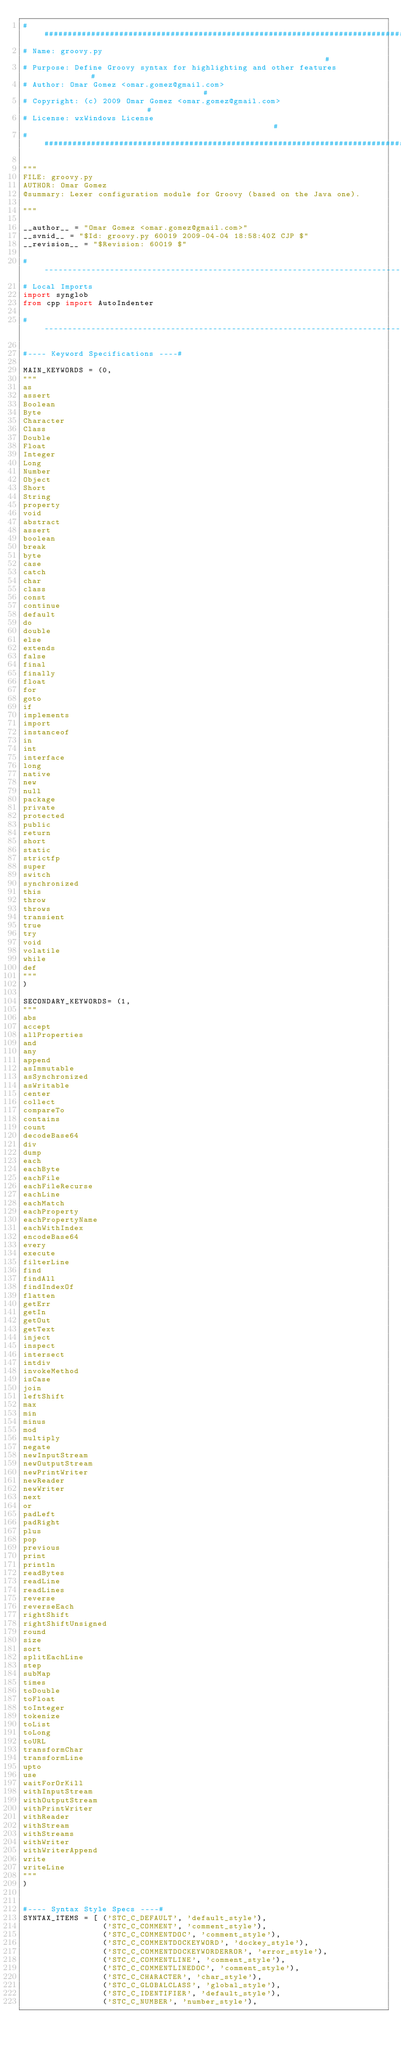<code> <loc_0><loc_0><loc_500><loc_500><_Python_>###############################################################################
# Name: groovy.py                                                             #
# Purpose: Define Groovy syntax for highlighting and other features           #
# Author: Omar Gomez <omar.gomez@gmail.com>                                   #
# Copyright: (c) 2009 Omar Gomez <omar.gomez@gmail.com>                       #
# License: wxWindows License                                                  #
###############################################################################

"""
FILE: groovy.py
AUTHOR: Omar Gomez
@summary: Lexer configuration module for Groovy (based on the Java one).

"""

__author__ = "Omar Gomez <omar.gomez@gmail.com>"
__svnid__ = "$Id: groovy.py 60019 2009-04-04 18:58:40Z CJP $"
__revision__ = "$Revision: 60019 $"

#-----------------------------------------------------------------------------#
# Local Imports
import synglob
from cpp import AutoIndenter

#-----------------------------------------------------------------------------#

#---- Keyword Specifications ----#

MAIN_KEYWORDS = (0, 
"""
as
assert
Boolean
Byte
Character
Class
Double
Float
Integer
Long
Number
Object
Short
String
property
void
abstract
assert
boolean
break
byte
case
catch
char
class
const
continue
default
do
double
else
extends
false
final
finally
float
for
goto
if
implements
import
instanceof
in
int
interface
long
native
new
null
package
private
protected
public
return
short
static
strictfp
super
switch
synchronized
this
throw
throws
transient
true
try
void
volatile
while
def
"""
)

SECONDARY_KEYWORDS= (1, 
"""
abs
accept
allProperties
and
any
append
asImmutable
asSynchronized
asWritable
center
collect
compareTo
contains
count
decodeBase64
div
dump
each
eachByte
eachFile
eachFileRecurse
eachLine
eachMatch
eachProperty
eachPropertyName
eachWithIndex
encodeBase64
every
execute
filterLine
find
findAll
findIndexOf
flatten
getErr
getIn
getOut
getText
inject
inspect
intersect
intdiv
invokeMethod
isCase
join
leftShift
max
min
minus
mod
multiply
negate
newInputStream
newOutputStream
newPrintWriter
newReader
newWriter
next
or
padLeft
padRight
plus
pop
previous
print
println
readBytes
readLine
readLines
reverse
reverseEach
rightShift
rightShiftUnsigned
round
size
sort
splitEachLine
step
subMap
times
toDouble
toFloat
toInteger
tokenize
toList
toLong
toURL
transformChar
transformLine
upto
use
waitForOrKill
withInputStream
withOutputStream
withPrintWriter
withReader
withStream
withStreams
withWriter
withWriterAppend
write
writeLine
"""
)


#---- Syntax Style Specs ----#
SYNTAX_ITEMS = [ ('STC_C_DEFAULT', 'default_style'),
                 ('STC_C_COMMENT', 'comment_style'),
                 ('STC_C_COMMENTDOC', 'comment_style'),
                 ('STC_C_COMMENTDOCKEYWORD', 'dockey_style'),
                 ('STC_C_COMMENTDOCKEYWORDERROR', 'error_style'),
                 ('STC_C_COMMENTLINE', 'comment_style'),
                 ('STC_C_COMMENTLINEDOC', 'comment_style'),
                 ('STC_C_CHARACTER', 'char_style'),
                 ('STC_C_GLOBALCLASS', 'global_style'),
                 ('STC_C_IDENTIFIER', 'default_style'),
                 ('STC_C_NUMBER', 'number_style'),</code> 